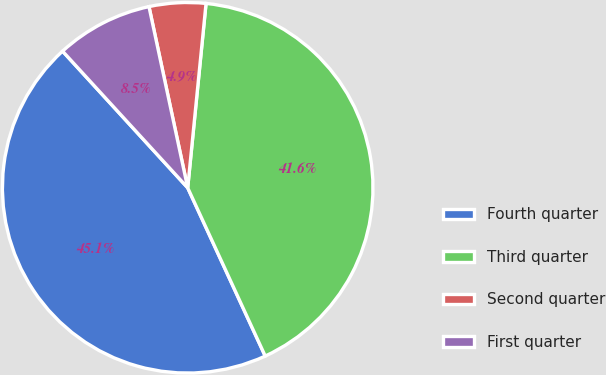Convert chart to OTSL. <chart><loc_0><loc_0><loc_500><loc_500><pie_chart><fcel>Fourth quarter<fcel>Third quarter<fcel>Second quarter<fcel>First quarter<nl><fcel>45.07%<fcel>41.55%<fcel>4.93%<fcel>8.45%<nl></chart> 